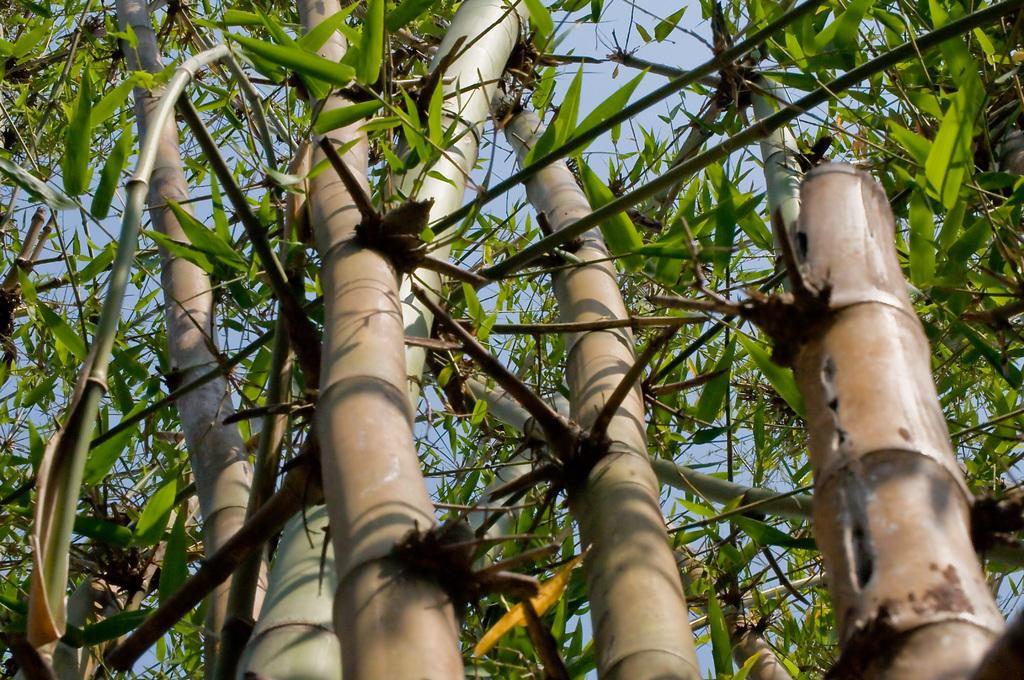What type of trees are in the image? There are bamboo trees in the image. Where are the bamboo trees located in the image? The bamboo trees are in the front of the image. What is visible above the bamboo trees in the image? The sky is visible above the bamboo trees in the image. Can you see any trucks driving through the bamboo trees in the image? There are no trucks visible in the image; it only features bamboo trees and the sky. What type of trousers are being worn by the bamboo trees in the image? Bamboo trees do not wear trousers, as they are plants and not humans. 